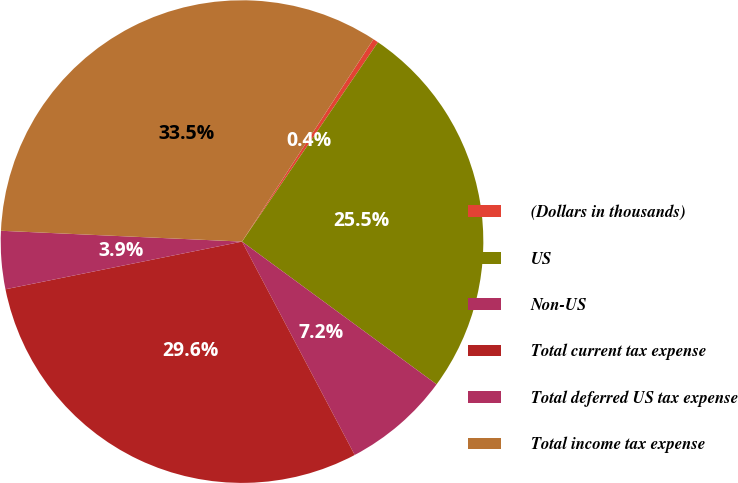Convert chart. <chart><loc_0><loc_0><loc_500><loc_500><pie_chart><fcel>(Dollars in thousands)<fcel>US<fcel>Non-US<fcel>Total current tax expense<fcel>Total deferred US tax expense<fcel>Total income tax expense<nl><fcel>0.36%<fcel>25.55%<fcel>7.19%<fcel>29.57%<fcel>3.88%<fcel>33.45%<nl></chart> 